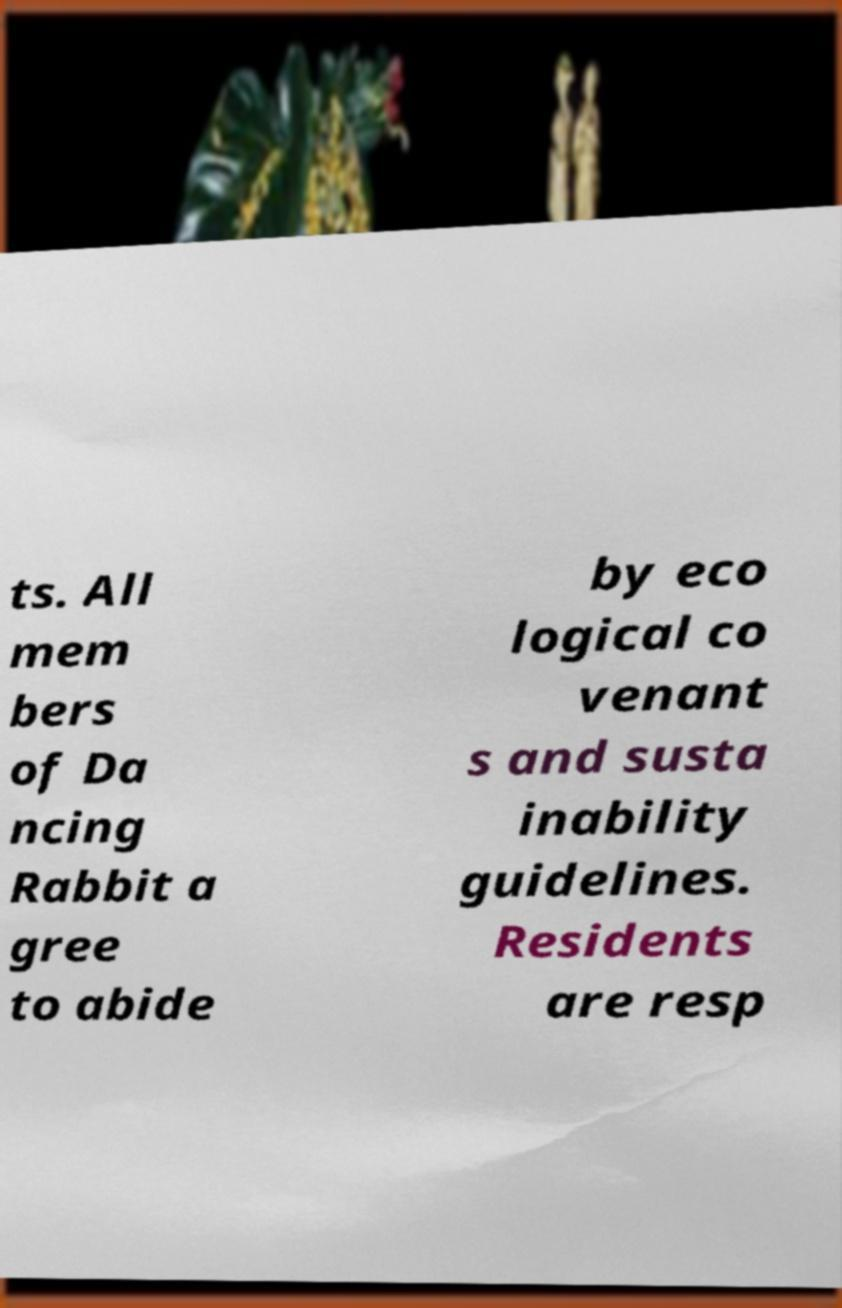Could you extract and type out the text from this image? ts. All mem bers of Da ncing Rabbit a gree to abide by eco logical co venant s and susta inability guidelines. Residents are resp 